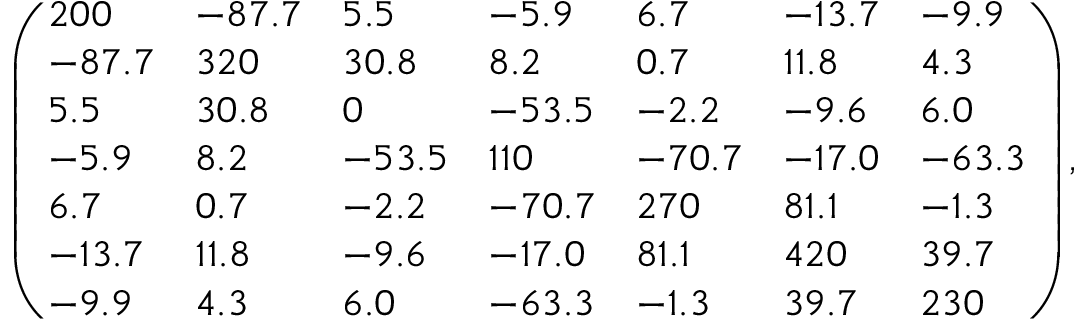Convert formula to latex. <formula><loc_0><loc_0><loc_500><loc_500>\left ( \begin{array} { l l l l l l l } { 2 0 0 } & { - 8 7 . 7 } & { 5 . 5 } & { - 5 . 9 } & { 6 . 7 } & { - 1 3 . 7 } & { - 9 . 9 } \\ { - 8 7 . 7 } & { 3 2 0 } & { 3 0 . 8 } & { 8 . 2 } & { 0 . 7 } & { 1 1 . 8 } & { 4 . 3 } \\ { 5 . 5 } & { 3 0 . 8 } & { 0 } & { - 5 3 . 5 } & { - 2 . 2 } & { - 9 . 6 } & { 6 . 0 } \\ { - 5 . 9 } & { 8 . 2 } & { - 5 3 . 5 } & { 1 1 0 } & { - 7 0 . 7 } & { - 1 7 . 0 } & { - 6 3 . 3 } \\ { 6 . 7 } & { 0 . 7 } & { - 2 . 2 } & { - 7 0 . 7 } & { 2 7 0 } & { 8 1 . 1 } & { - 1 . 3 } \\ { - 1 3 . 7 } & { 1 1 . 8 } & { - 9 . 6 } & { - 1 7 . 0 } & { 8 1 . 1 } & { 4 2 0 } & { 3 9 . 7 } \\ { - 9 . 9 } & { 4 . 3 } & { 6 . 0 } & { - 6 3 . 3 } & { - 1 . 3 } & { 3 9 . 7 } & { 2 3 0 } \end{array} \right ) ,</formula> 